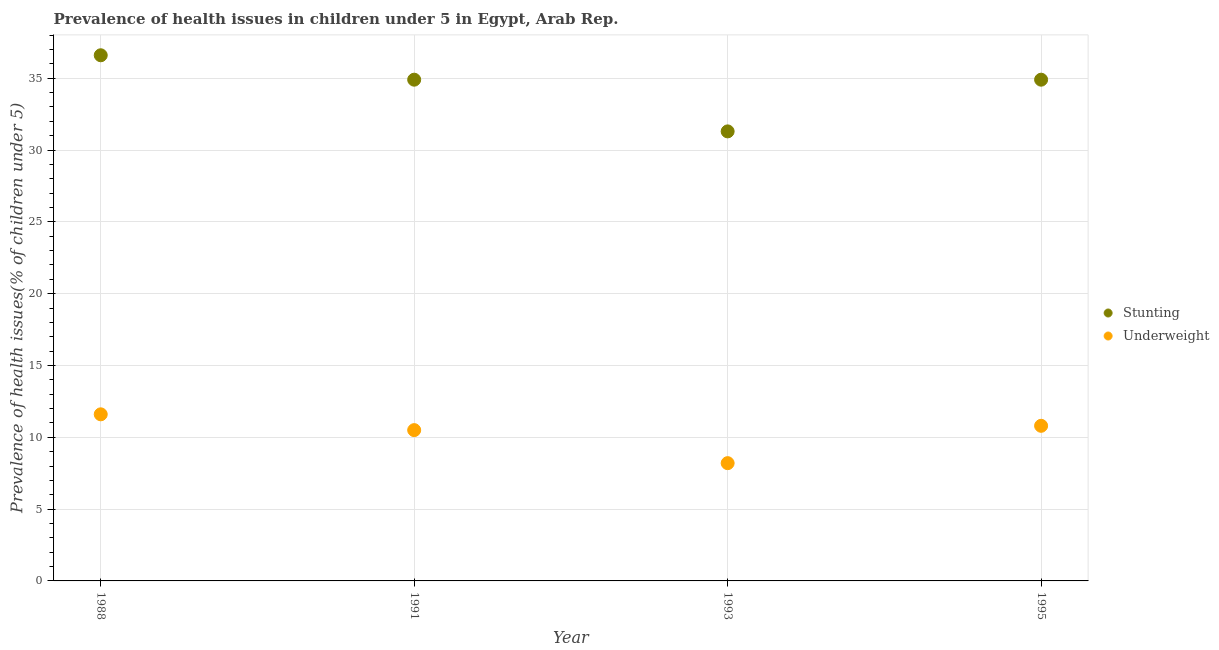How many different coloured dotlines are there?
Your response must be concise. 2. What is the percentage of underweight children in 1988?
Your answer should be very brief. 11.6. Across all years, what is the maximum percentage of stunted children?
Keep it short and to the point. 36.6. Across all years, what is the minimum percentage of underweight children?
Make the answer very short. 8.2. In which year was the percentage of underweight children maximum?
Your answer should be compact. 1988. In which year was the percentage of stunted children minimum?
Provide a short and direct response. 1993. What is the total percentage of stunted children in the graph?
Provide a succinct answer. 137.7. What is the difference between the percentage of stunted children in 1991 and that in 1993?
Provide a succinct answer. 3.6. What is the difference between the percentage of underweight children in 1995 and the percentage of stunted children in 1991?
Provide a short and direct response. -24.1. What is the average percentage of underweight children per year?
Your answer should be very brief. 10.28. In the year 1988, what is the difference between the percentage of underweight children and percentage of stunted children?
Ensure brevity in your answer.  -25. In how many years, is the percentage of stunted children greater than 37 %?
Your response must be concise. 0. What is the ratio of the percentage of underweight children in 1988 to that in 1995?
Ensure brevity in your answer.  1.07. Is the difference between the percentage of underweight children in 1993 and 1995 greater than the difference between the percentage of stunted children in 1993 and 1995?
Make the answer very short. Yes. What is the difference between the highest and the second highest percentage of stunted children?
Keep it short and to the point. 1.7. What is the difference between the highest and the lowest percentage of underweight children?
Provide a succinct answer. 3.4. In how many years, is the percentage of stunted children greater than the average percentage of stunted children taken over all years?
Make the answer very short. 3. Is the sum of the percentage of stunted children in 1988 and 1991 greater than the maximum percentage of underweight children across all years?
Make the answer very short. Yes. Is the percentage of stunted children strictly greater than the percentage of underweight children over the years?
Your response must be concise. Yes. How many years are there in the graph?
Your answer should be very brief. 4. Does the graph contain any zero values?
Your answer should be very brief. No. Does the graph contain grids?
Keep it short and to the point. Yes. How many legend labels are there?
Your answer should be very brief. 2. What is the title of the graph?
Your answer should be very brief. Prevalence of health issues in children under 5 in Egypt, Arab Rep. Does "Methane emissions" appear as one of the legend labels in the graph?
Your answer should be very brief. No. What is the label or title of the Y-axis?
Offer a very short reply. Prevalence of health issues(% of children under 5). What is the Prevalence of health issues(% of children under 5) in Stunting in 1988?
Your answer should be compact. 36.6. What is the Prevalence of health issues(% of children under 5) of Underweight in 1988?
Your answer should be very brief. 11.6. What is the Prevalence of health issues(% of children under 5) of Stunting in 1991?
Your answer should be compact. 34.9. What is the Prevalence of health issues(% of children under 5) of Stunting in 1993?
Keep it short and to the point. 31.3. What is the Prevalence of health issues(% of children under 5) in Underweight in 1993?
Make the answer very short. 8.2. What is the Prevalence of health issues(% of children under 5) in Stunting in 1995?
Provide a succinct answer. 34.9. What is the Prevalence of health issues(% of children under 5) in Underweight in 1995?
Your answer should be very brief. 10.8. Across all years, what is the maximum Prevalence of health issues(% of children under 5) of Stunting?
Make the answer very short. 36.6. Across all years, what is the maximum Prevalence of health issues(% of children under 5) of Underweight?
Offer a very short reply. 11.6. Across all years, what is the minimum Prevalence of health issues(% of children under 5) of Stunting?
Ensure brevity in your answer.  31.3. Across all years, what is the minimum Prevalence of health issues(% of children under 5) of Underweight?
Your answer should be very brief. 8.2. What is the total Prevalence of health issues(% of children under 5) in Stunting in the graph?
Give a very brief answer. 137.7. What is the total Prevalence of health issues(% of children under 5) in Underweight in the graph?
Provide a short and direct response. 41.1. What is the difference between the Prevalence of health issues(% of children under 5) in Stunting in 1988 and that in 1991?
Ensure brevity in your answer.  1.7. What is the difference between the Prevalence of health issues(% of children under 5) of Underweight in 1988 and that in 1993?
Keep it short and to the point. 3.4. What is the difference between the Prevalence of health issues(% of children under 5) of Stunting in 1991 and that in 1993?
Your answer should be compact. 3.6. What is the difference between the Prevalence of health issues(% of children under 5) of Underweight in 1991 and that in 1993?
Offer a very short reply. 2.3. What is the difference between the Prevalence of health issues(% of children under 5) in Underweight in 1991 and that in 1995?
Offer a terse response. -0.3. What is the difference between the Prevalence of health issues(% of children under 5) in Stunting in 1993 and that in 1995?
Offer a very short reply. -3.6. What is the difference between the Prevalence of health issues(% of children under 5) in Stunting in 1988 and the Prevalence of health issues(% of children under 5) in Underweight in 1991?
Give a very brief answer. 26.1. What is the difference between the Prevalence of health issues(% of children under 5) in Stunting in 1988 and the Prevalence of health issues(% of children under 5) in Underweight in 1993?
Ensure brevity in your answer.  28.4. What is the difference between the Prevalence of health issues(% of children under 5) in Stunting in 1988 and the Prevalence of health issues(% of children under 5) in Underweight in 1995?
Offer a very short reply. 25.8. What is the difference between the Prevalence of health issues(% of children under 5) in Stunting in 1991 and the Prevalence of health issues(% of children under 5) in Underweight in 1993?
Offer a very short reply. 26.7. What is the difference between the Prevalence of health issues(% of children under 5) in Stunting in 1991 and the Prevalence of health issues(% of children under 5) in Underweight in 1995?
Your response must be concise. 24.1. What is the difference between the Prevalence of health issues(% of children under 5) of Stunting in 1993 and the Prevalence of health issues(% of children under 5) of Underweight in 1995?
Make the answer very short. 20.5. What is the average Prevalence of health issues(% of children under 5) of Stunting per year?
Your answer should be compact. 34.42. What is the average Prevalence of health issues(% of children under 5) of Underweight per year?
Your answer should be compact. 10.28. In the year 1991, what is the difference between the Prevalence of health issues(% of children under 5) in Stunting and Prevalence of health issues(% of children under 5) in Underweight?
Offer a terse response. 24.4. In the year 1993, what is the difference between the Prevalence of health issues(% of children under 5) of Stunting and Prevalence of health issues(% of children under 5) of Underweight?
Ensure brevity in your answer.  23.1. In the year 1995, what is the difference between the Prevalence of health issues(% of children under 5) of Stunting and Prevalence of health issues(% of children under 5) of Underweight?
Your answer should be very brief. 24.1. What is the ratio of the Prevalence of health issues(% of children under 5) of Stunting in 1988 to that in 1991?
Ensure brevity in your answer.  1.05. What is the ratio of the Prevalence of health issues(% of children under 5) in Underweight in 1988 to that in 1991?
Your response must be concise. 1.1. What is the ratio of the Prevalence of health issues(% of children under 5) in Stunting in 1988 to that in 1993?
Your response must be concise. 1.17. What is the ratio of the Prevalence of health issues(% of children under 5) of Underweight in 1988 to that in 1993?
Offer a terse response. 1.41. What is the ratio of the Prevalence of health issues(% of children under 5) of Stunting in 1988 to that in 1995?
Provide a succinct answer. 1.05. What is the ratio of the Prevalence of health issues(% of children under 5) in Underweight in 1988 to that in 1995?
Ensure brevity in your answer.  1.07. What is the ratio of the Prevalence of health issues(% of children under 5) in Stunting in 1991 to that in 1993?
Provide a short and direct response. 1.11. What is the ratio of the Prevalence of health issues(% of children under 5) in Underweight in 1991 to that in 1993?
Keep it short and to the point. 1.28. What is the ratio of the Prevalence of health issues(% of children under 5) in Underweight in 1991 to that in 1995?
Offer a terse response. 0.97. What is the ratio of the Prevalence of health issues(% of children under 5) of Stunting in 1993 to that in 1995?
Keep it short and to the point. 0.9. What is the ratio of the Prevalence of health issues(% of children under 5) of Underweight in 1993 to that in 1995?
Offer a very short reply. 0.76. What is the difference between the highest and the second highest Prevalence of health issues(% of children under 5) of Stunting?
Provide a succinct answer. 1.7. What is the difference between the highest and the lowest Prevalence of health issues(% of children under 5) in Underweight?
Give a very brief answer. 3.4. 